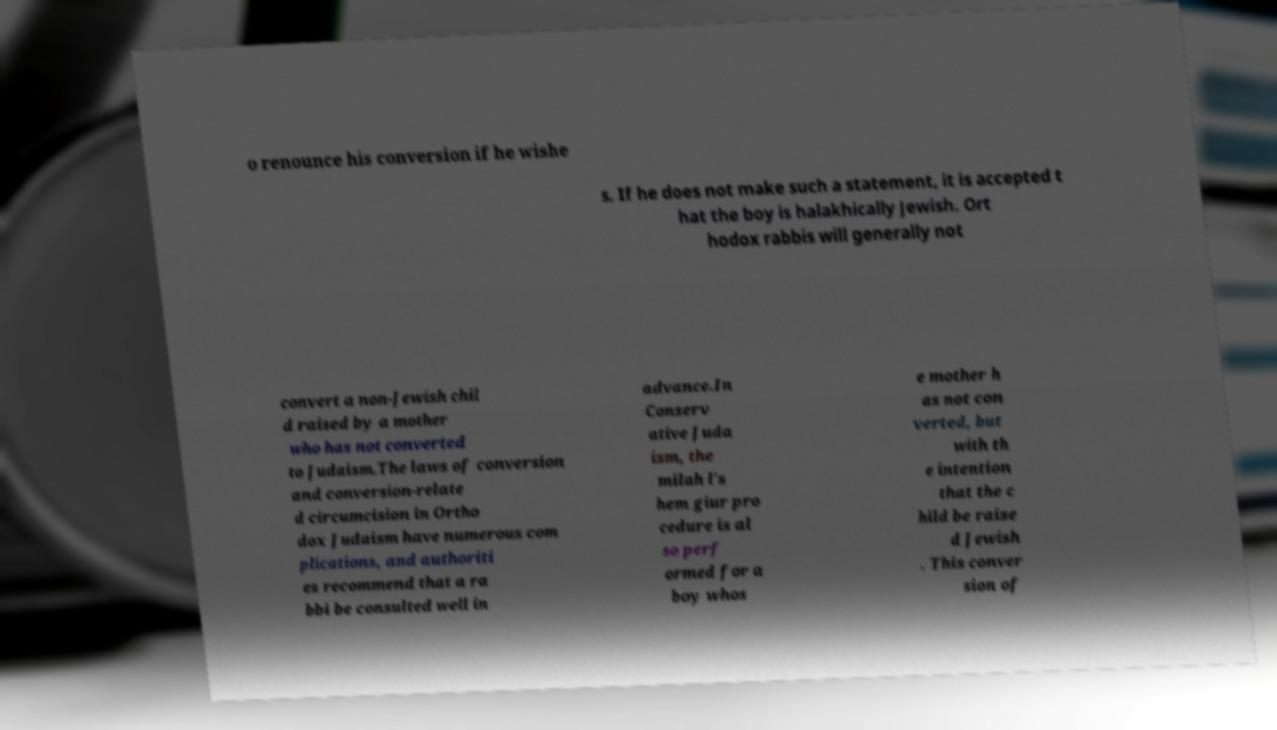Please identify and transcribe the text found in this image. o renounce his conversion if he wishe s. If he does not make such a statement, it is accepted t hat the boy is halakhically Jewish. Ort hodox rabbis will generally not convert a non-Jewish chil d raised by a mother who has not converted to Judaism.The laws of conversion and conversion-relate d circumcision in Ortho dox Judaism have numerous com plications, and authoriti es recommend that a ra bbi be consulted well in advance.In Conserv ative Juda ism, the milah l's hem giur pro cedure is al so perf ormed for a boy whos e mother h as not con verted, but with th e intention that the c hild be raise d Jewish . This conver sion of 